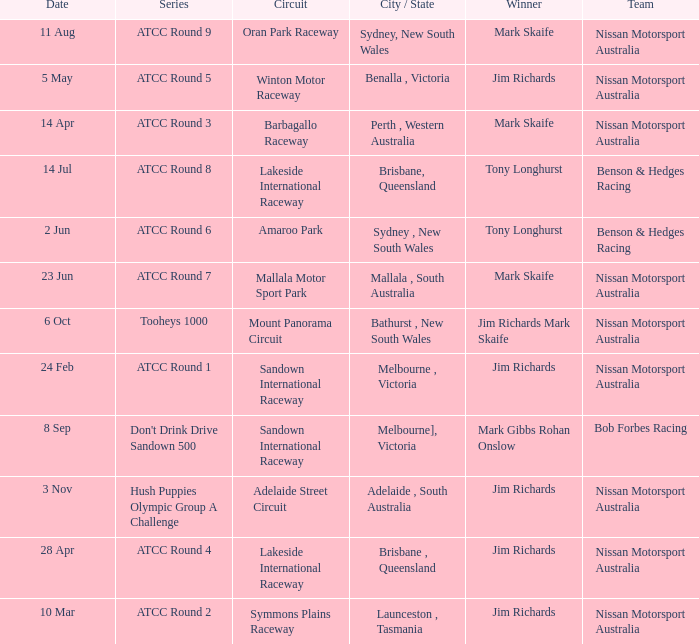What is the Circuit in the ATCC Round 1 Series with Winner Jim Richards? Sandown International Raceway. 